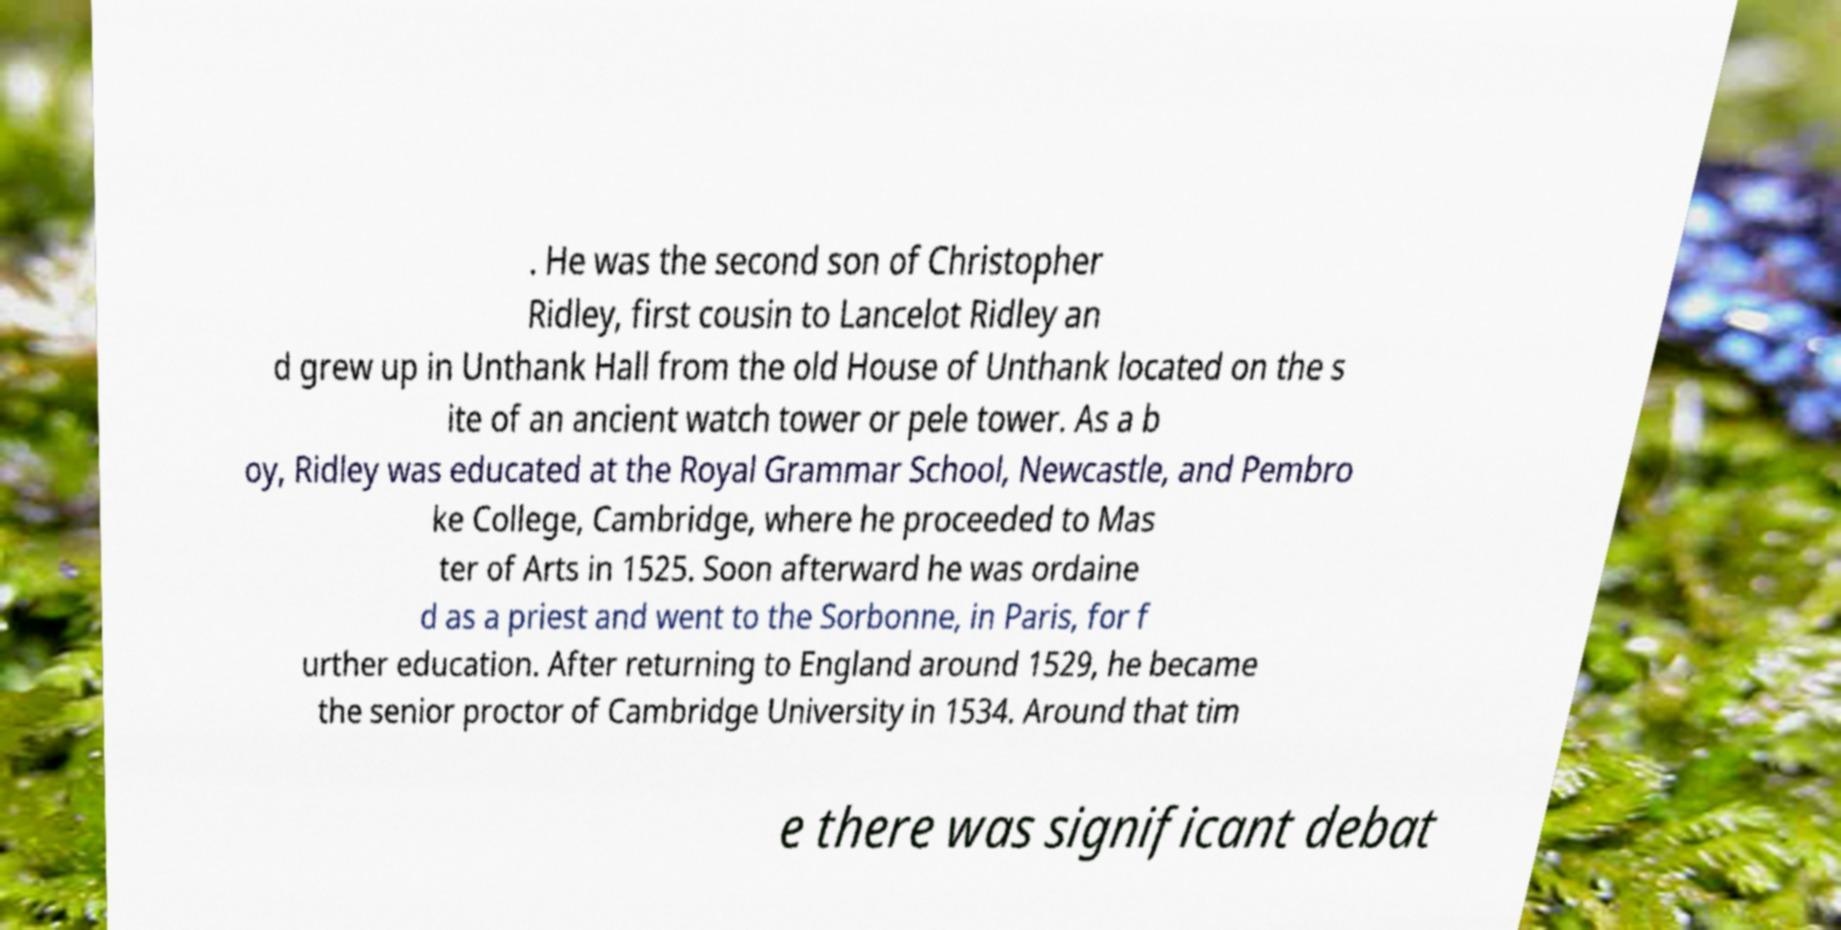What messages or text are displayed in this image? I need them in a readable, typed format. . He was the second son of Christopher Ridley, first cousin to Lancelot Ridley an d grew up in Unthank Hall from the old House of Unthank located on the s ite of an ancient watch tower or pele tower. As a b oy, Ridley was educated at the Royal Grammar School, Newcastle, and Pembro ke College, Cambridge, where he proceeded to Mas ter of Arts in 1525. Soon afterward he was ordaine d as a priest and went to the Sorbonne, in Paris, for f urther education. After returning to England around 1529, he became the senior proctor of Cambridge University in 1534. Around that tim e there was significant debat 